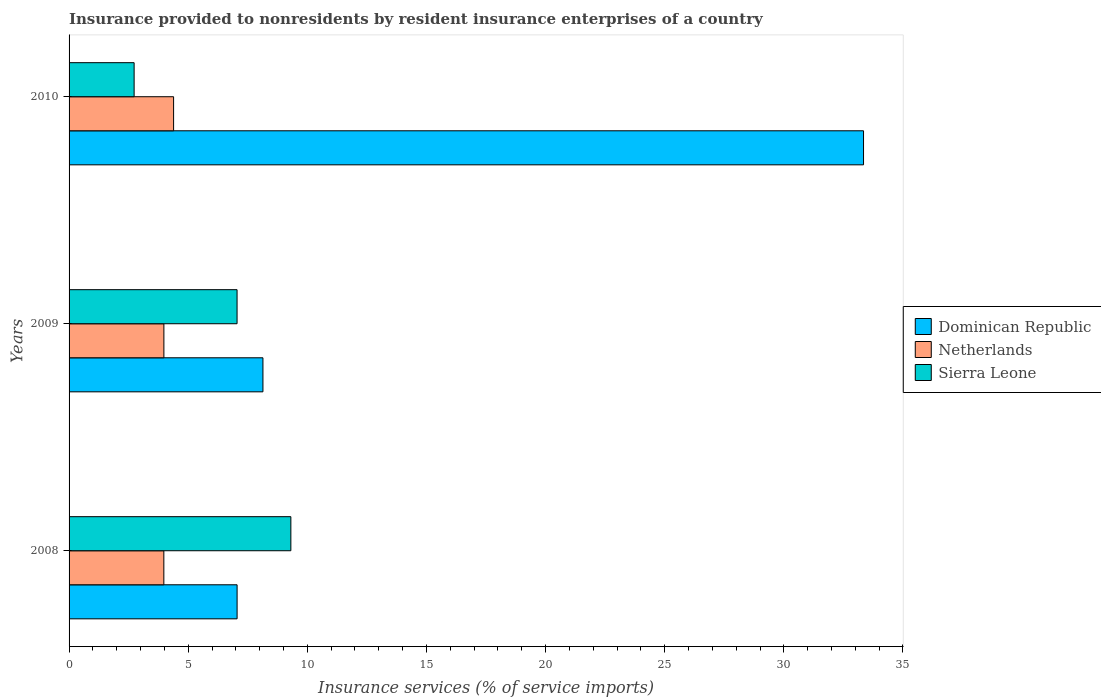How many different coloured bars are there?
Give a very brief answer. 3. How many groups of bars are there?
Keep it short and to the point. 3. How many bars are there on the 1st tick from the top?
Keep it short and to the point. 3. What is the label of the 3rd group of bars from the top?
Offer a very short reply. 2008. In how many cases, is the number of bars for a given year not equal to the number of legend labels?
Make the answer very short. 0. What is the insurance provided to nonresidents in Sierra Leone in 2008?
Keep it short and to the point. 9.31. Across all years, what is the maximum insurance provided to nonresidents in Dominican Republic?
Offer a very short reply. 33.35. Across all years, what is the minimum insurance provided to nonresidents in Dominican Republic?
Keep it short and to the point. 7.05. In which year was the insurance provided to nonresidents in Netherlands maximum?
Provide a short and direct response. 2010. In which year was the insurance provided to nonresidents in Netherlands minimum?
Make the answer very short. 2008. What is the total insurance provided to nonresidents in Dominican Republic in the graph?
Keep it short and to the point. 48.53. What is the difference between the insurance provided to nonresidents in Dominican Republic in 2008 and that in 2009?
Make the answer very short. -1.08. What is the difference between the insurance provided to nonresidents in Netherlands in 2010 and the insurance provided to nonresidents in Dominican Republic in 2008?
Keep it short and to the point. -2.67. What is the average insurance provided to nonresidents in Netherlands per year?
Offer a terse response. 4.11. In the year 2008, what is the difference between the insurance provided to nonresidents in Dominican Republic and insurance provided to nonresidents in Sierra Leone?
Your answer should be compact. -2.26. What is the ratio of the insurance provided to nonresidents in Sierra Leone in 2008 to that in 2009?
Provide a succinct answer. 1.32. What is the difference between the highest and the second highest insurance provided to nonresidents in Netherlands?
Your answer should be compact. 0.41. What is the difference between the highest and the lowest insurance provided to nonresidents in Dominican Republic?
Offer a very short reply. 26.29. Is the sum of the insurance provided to nonresidents in Sierra Leone in 2008 and 2009 greater than the maximum insurance provided to nonresidents in Netherlands across all years?
Your response must be concise. Yes. What does the 1st bar from the bottom in 2010 represents?
Ensure brevity in your answer.  Dominican Republic. Is it the case that in every year, the sum of the insurance provided to nonresidents in Dominican Republic and insurance provided to nonresidents in Sierra Leone is greater than the insurance provided to nonresidents in Netherlands?
Make the answer very short. Yes. How many bars are there?
Keep it short and to the point. 9. Does the graph contain any zero values?
Your response must be concise. No. How many legend labels are there?
Give a very brief answer. 3. What is the title of the graph?
Give a very brief answer. Insurance provided to nonresidents by resident insurance enterprises of a country. What is the label or title of the X-axis?
Ensure brevity in your answer.  Insurance services (% of service imports). What is the label or title of the Y-axis?
Your answer should be compact. Years. What is the Insurance services (% of service imports) of Dominican Republic in 2008?
Provide a short and direct response. 7.05. What is the Insurance services (% of service imports) of Netherlands in 2008?
Provide a short and direct response. 3.98. What is the Insurance services (% of service imports) of Sierra Leone in 2008?
Your answer should be compact. 9.31. What is the Insurance services (% of service imports) in Dominican Republic in 2009?
Make the answer very short. 8.14. What is the Insurance services (% of service imports) in Netherlands in 2009?
Your response must be concise. 3.98. What is the Insurance services (% of service imports) in Sierra Leone in 2009?
Your answer should be compact. 7.05. What is the Insurance services (% of service imports) in Dominican Republic in 2010?
Offer a terse response. 33.35. What is the Insurance services (% of service imports) of Netherlands in 2010?
Offer a very short reply. 4.39. What is the Insurance services (% of service imports) of Sierra Leone in 2010?
Your answer should be very brief. 2.73. Across all years, what is the maximum Insurance services (% of service imports) of Dominican Republic?
Ensure brevity in your answer.  33.35. Across all years, what is the maximum Insurance services (% of service imports) of Netherlands?
Provide a succinct answer. 4.39. Across all years, what is the maximum Insurance services (% of service imports) in Sierra Leone?
Offer a terse response. 9.31. Across all years, what is the minimum Insurance services (% of service imports) of Dominican Republic?
Make the answer very short. 7.05. Across all years, what is the minimum Insurance services (% of service imports) in Netherlands?
Provide a succinct answer. 3.98. Across all years, what is the minimum Insurance services (% of service imports) in Sierra Leone?
Provide a short and direct response. 2.73. What is the total Insurance services (% of service imports) of Dominican Republic in the graph?
Offer a very short reply. 48.53. What is the total Insurance services (% of service imports) in Netherlands in the graph?
Offer a very short reply. 12.34. What is the total Insurance services (% of service imports) of Sierra Leone in the graph?
Ensure brevity in your answer.  19.09. What is the difference between the Insurance services (% of service imports) in Dominican Republic in 2008 and that in 2009?
Offer a very short reply. -1.08. What is the difference between the Insurance services (% of service imports) of Netherlands in 2008 and that in 2009?
Your answer should be very brief. -0. What is the difference between the Insurance services (% of service imports) of Sierra Leone in 2008 and that in 2009?
Make the answer very short. 2.26. What is the difference between the Insurance services (% of service imports) in Dominican Republic in 2008 and that in 2010?
Provide a succinct answer. -26.29. What is the difference between the Insurance services (% of service imports) of Netherlands in 2008 and that in 2010?
Your answer should be compact. -0.41. What is the difference between the Insurance services (% of service imports) in Sierra Leone in 2008 and that in 2010?
Offer a very short reply. 6.58. What is the difference between the Insurance services (% of service imports) of Dominican Republic in 2009 and that in 2010?
Keep it short and to the point. -25.21. What is the difference between the Insurance services (% of service imports) in Netherlands in 2009 and that in 2010?
Offer a very short reply. -0.41. What is the difference between the Insurance services (% of service imports) of Sierra Leone in 2009 and that in 2010?
Provide a succinct answer. 4.32. What is the difference between the Insurance services (% of service imports) in Dominican Republic in 2008 and the Insurance services (% of service imports) in Netherlands in 2009?
Offer a very short reply. 3.07. What is the difference between the Insurance services (% of service imports) of Dominican Republic in 2008 and the Insurance services (% of service imports) of Sierra Leone in 2009?
Ensure brevity in your answer.  0. What is the difference between the Insurance services (% of service imports) of Netherlands in 2008 and the Insurance services (% of service imports) of Sierra Leone in 2009?
Your answer should be compact. -3.07. What is the difference between the Insurance services (% of service imports) in Dominican Republic in 2008 and the Insurance services (% of service imports) in Netherlands in 2010?
Offer a terse response. 2.67. What is the difference between the Insurance services (% of service imports) in Dominican Republic in 2008 and the Insurance services (% of service imports) in Sierra Leone in 2010?
Give a very brief answer. 4.32. What is the difference between the Insurance services (% of service imports) in Netherlands in 2008 and the Insurance services (% of service imports) in Sierra Leone in 2010?
Offer a terse response. 1.25. What is the difference between the Insurance services (% of service imports) in Dominican Republic in 2009 and the Insurance services (% of service imports) in Netherlands in 2010?
Ensure brevity in your answer.  3.75. What is the difference between the Insurance services (% of service imports) of Dominican Republic in 2009 and the Insurance services (% of service imports) of Sierra Leone in 2010?
Your response must be concise. 5.41. What is the difference between the Insurance services (% of service imports) of Netherlands in 2009 and the Insurance services (% of service imports) of Sierra Leone in 2010?
Your response must be concise. 1.25. What is the average Insurance services (% of service imports) in Dominican Republic per year?
Offer a very short reply. 16.18. What is the average Insurance services (% of service imports) of Netherlands per year?
Offer a very short reply. 4.12. What is the average Insurance services (% of service imports) in Sierra Leone per year?
Give a very brief answer. 6.36. In the year 2008, what is the difference between the Insurance services (% of service imports) of Dominican Republic and Insurance services (% of service imports) of Netherlands?
Offer a terse response. 3.07. In the year 2008, what is the difference between the Insurance services (% of service imports) in Dominican Republic and Insurance services (% of service imports) in Sierra Leone?
Your answer should be very brief. -2.26. In the year 2008, what is the difference between the Insurance services (% of service imports) of Netherlands and Insurance services (% of service imports) of Sierra Leone?
Provide a succinct answer. -5.33. In the year 2009, what is the difference between the Insurance services (% of service imports) in Dominican Republic and Insurance services (% of service imports) in Netherlands?
Offer a very short reply. 4.16. In the year 2009, what is the difference between the Insurance services (% of service imports) in Dominican Republic and Insurance services (% of service imports) in Sierra Leone?
Your answer should be very brief. 1.09. In the year 2009, what is the difference between the Insurance services (% of service imports) in Netherlands and Insurance services (% of service imports) in Sierra Leone?
Keep it short and to the point. -3.07. In the year 2010, what is the difference between the Insurance services (% of service imports) in Dominican Republic and Insurance services (% of service imports) in Netherlands?
Give a very brief answer. 28.96. In the year 2010, what is the difference between the Insurance services (% of service imports) of Dominican Republic and Insurance services (% of service imports) of Sierra Leone?
Offer a very short reply. 30.62. In the year 2010, what is the difference between the Insurance services (% of service imports) of Netherlands and Insurance services (% of service imports) of Sierra Leone?
Give a very brief answer. 1.66. What is the ratio of the Insurance services (% of service imports) in Dominican Republic in 2008 to that in 2009?
Give a very brief answer. 0.87. What is the ratio of the Insurance services (% of service imports) of Netherlands in 2008 to that in 2009?
Offer a terse response. 1. What is the ratio of the Insurance services (% of service imports) in Sierra Leone in 2008 to that in 2009?
Offer a terse response. 1.32. What is the ratio of the Insurance services (% of service imports) in Dominican Republic in 2008 to that in 2010?
Ensure brevity in your answer.  0.21. What is the ratio of the Insurance services (% of service imports) of Netherlands in 2008 to that in 2010?
Give a very brief answer. 0.91. What is the ratio of the Insurance services (% of service imports) of Sierra Leone in 2008 to that in 2010?
Make the answer very short. 3.41. What is the ratio of the Insurance services (% of service imports) of Dominican Republic in 2009 to that in 2010?
Keep it short and to the point. 0.24. What is the ratio of the Insurance services (% of service imports) in Netherlands in 2009 to that in 2010?
Offer a very short reply. 0.91. What is the ratio of the Insurance services (% of service imports) of Sierra Leone in 2009 to that in 2010?
Your answer should be very brief. 2.58. What is the difference between the highest and the second highest Insurance services (% of service imports) of Dominican Republic?
Give a very brief answer. 25.21. What is the difference between the highest and the second highest Insurance services (% of service imports) in Netherlands?
Keep it short and to the point. 0.41. What is the difference between the highest and the second highest Insurance services (% of service imports) in Sierra Leone?
Your answer should be compact. 2.26. What is the difference between the highest and the lowest Insurance services (% of service imports) in Dominican Republic?
Keep it short and to the point. 26.29. What is the difference between the highest and the lowest Insurance services (% of service imports) in Netherlands?
Offer a terse response. 0.41. What is the difference between the highest and the lowest Insurance services (% of service imports) in Sierra Leone?
Your answer should be very brief. 6.58. 